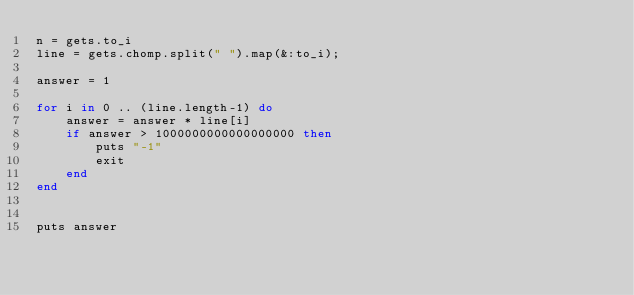Convert code to text. <code><loc_0><loc_0><loc_500><loc_500><_Ruby_>n = gets.to_i
line = gets.chomp.split(" ").map(&:to_i);

answer = 1

for i in 0 .. (line.length-1) do
	answer = answer * line[i]
	if answer > 1000000000000000000 then
		puts "-1"
		exit
	end
end


puts answer</code> 